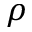Convert formula to latex. <formula><loc_0><loc_0><loc_500><loc_500>\rho</formula> 